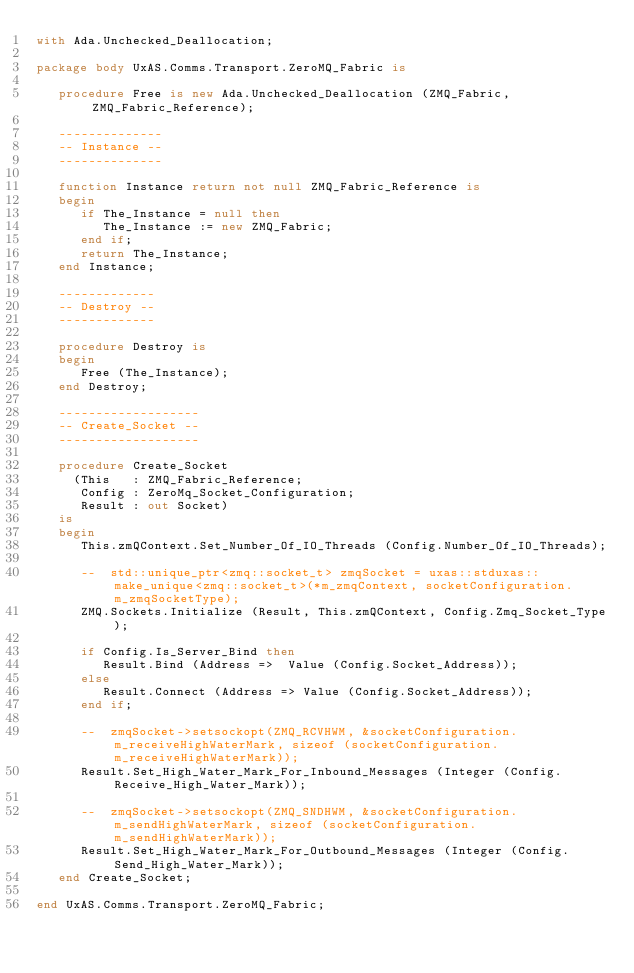<code> <loc_0><loc_0><loc_500><loc_500><_Ada_>with Ada.Unchecked_Deallocation;

package body UxAS.Comms.Transport.ZeroMQ_Fabric is

   procedure Free is new Ada.Unchecked_Deallocation (ZMQ_Fabric, ZMQ_Fabric_Reference);

   --------------
   -- Instance --
   --------------

   function Instance return not null ZMQ_Fabric_Reference is
   begin
      if The_Instance = null then
         The_Instance := new ZMQ_Fabric;
      end if;
      return The_Instance;
   end Instance;

   -------------
   -- Destroy --
   -------------

   procedure Destroy is
   begin
      Free (The_Instance);
   end Destroy;

   -------------------
   -- Create_Socket --
   -------------------

   procedure Create_Socket
     (This   : ZMQ_Fabric_Reference;
      Config : ZeroMq_Socket_Configuration;
      Result : out Socket)
   is
   begin
      This.zmQContext.Set_Number_Of_IO_Threads (Config.Number_Of_IO_Threads);

      --  std::unique_ptr<zmq::socket_t> zmqSocket = uxas::stduxas::make_unique<zmq::socket_t>(*m_zmqContext, socketConfiguration.m_zmqSocketType);
      ZMQ.Sockets.Initialize (Result, This.zmQContext, Config.Zmq_Socket_Type);

      if Config.Is_Server_Bind then
         Result.Bind (Address =>  Value (Config.Socket_Address));
      else
         Result.Connect (Address => Value (Config.Socket_Address));
      end if;

      --  zmqSocket->setsockopt(ZMQ_RCVHWM, &socketConfiguration.m_receiveHighWaterMark, sizeof (socketConfiguration.m_receiveHighWaterMark));
      Result.Set_High_Water_Mark_For_Inbound_Messages (Integer (Config.Receive_High_Water_Mark));

      --  zmqSocket->setsockopt(ZMQ_SNDHWM, &socketConfiguration.m_sendHighWaterMark, sizeof (socketConfiguration.m_sendHighWaterMark));
      Result.Set_High_Water_Mark_For_Outbound_Messages (Integer (Config.Send_High_Water_Mark));
   end Create_Socket;

end UxAS.Comms.Transport.ZeroMQ_Fabric;
</code> 